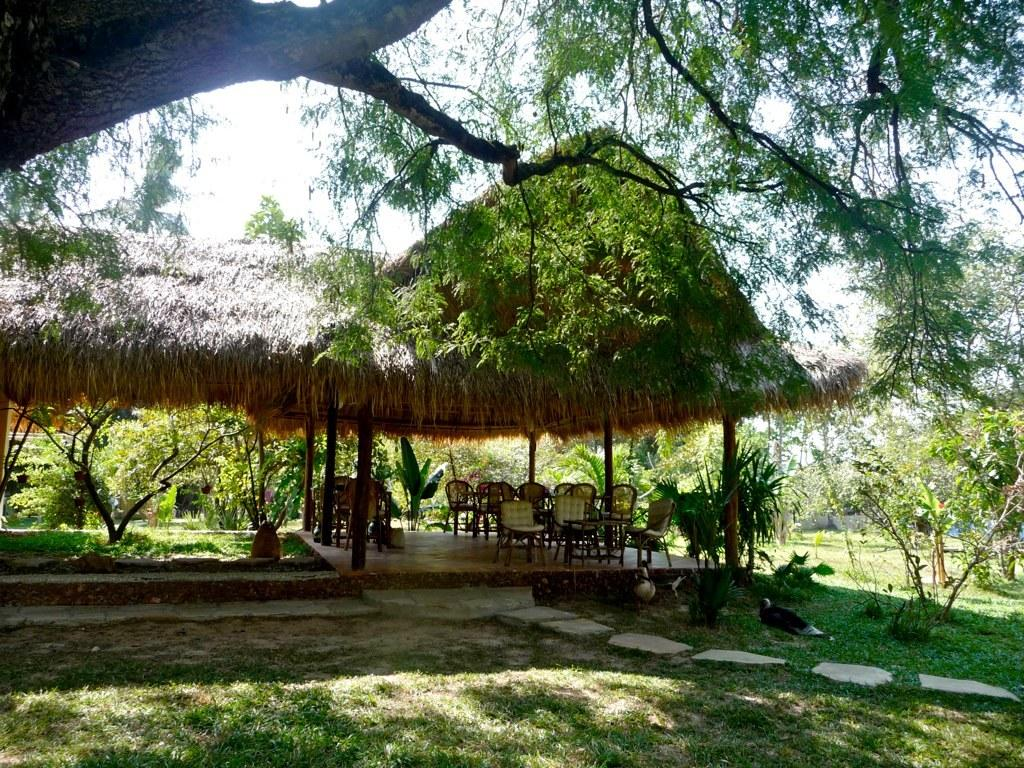What type of furniture is present in the image? There are chairs in the image. What colors are the chairs? The chairs are in cream and brown colors. What can be seen in the background of the image? There are plants and trees in the background of the image. What color are the plants and trees? The plants and trees are green in color. What is visible in the background of the image besides the plants and trees? The sky is visible in the background of the image. What color is the sky? The sky is white in color. What direction are the stems of the plants growing in the image? There are no stems visible in the image, as only the leaves and branches of the plants can be seen. 